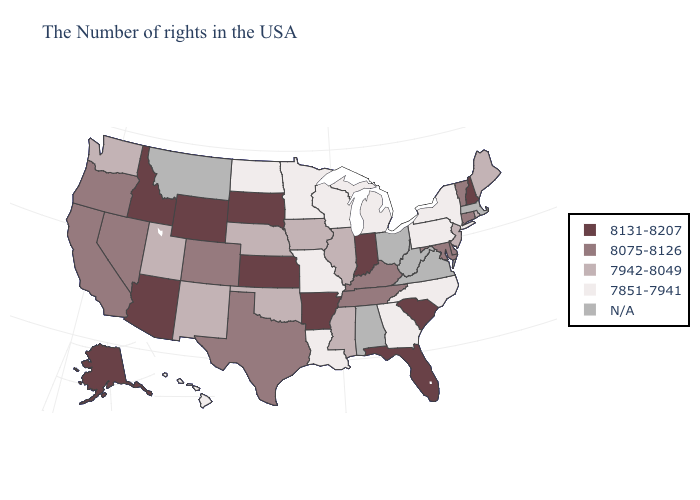Name the states that have a value in the range 7851-7941?
Concise answer only. New York, Pennsylvania, North Carolina, Georgia, Michigan, Wisconsin, Louisiana, Missouri, Minnesota, North Dakota, Hawaii. Name the states that have a value in the range 8075-8126?
Quick response, please. Vermont, Connecticut, Delaware, Maryland, Kentucky, Tennessee, Texas, Colorado, Nevada, California, Oregon. Does New Hampshire have the lowest value in the USA?
Quick response, please. No. What is the value of Wyoming?
Write a very short answer. 8131-8207. Is the legend a continuous bar?
Concise answer only. No. Name the states that have a value in the range 7942-8049?
Concise answer only. Maine, Rhode Island, New Jersey, Illinois, Mississippi, Iowa, Nebraska, Oklahoma, New Mexico, Utah, Washington. Among the states that border Colorado , does Wyoming have the highest value?
Quick response, please. Yes. What is the highest value in states that border Wyoming?
Write a very short answer. 8131-8207. Name the states that have a value in the range 8075-8126?
Be succinct. Vermont, Connecticut, Delaware, Maryland, Kentucky, Tennessee, Texas, Colorado, Nevada, California, Oregon. Name the states that have a value in the range 7851-7941?
Be succinct. New York, Pennsylvania, North Carolina, Georgia, Michigan, Wisconsin, Louisiana, Missouri, Minnesota, North Dakota, Hawaii. Which states have the lowest value in the Northeast?
Quick response, please. New York, Pennsylvania. What is the value of Hawaii?
Be succinct. 7851-7941. What is the value of Nevada?
Write a very short answer. 8075-8126. Does Nebraska have the highest value in the USA?
Short answer required. No. Which states have the lowest value in the MidWest?
Write a very short answer. Michigan, Wisconsin, Missouri, Minnesota, North Dakota. 